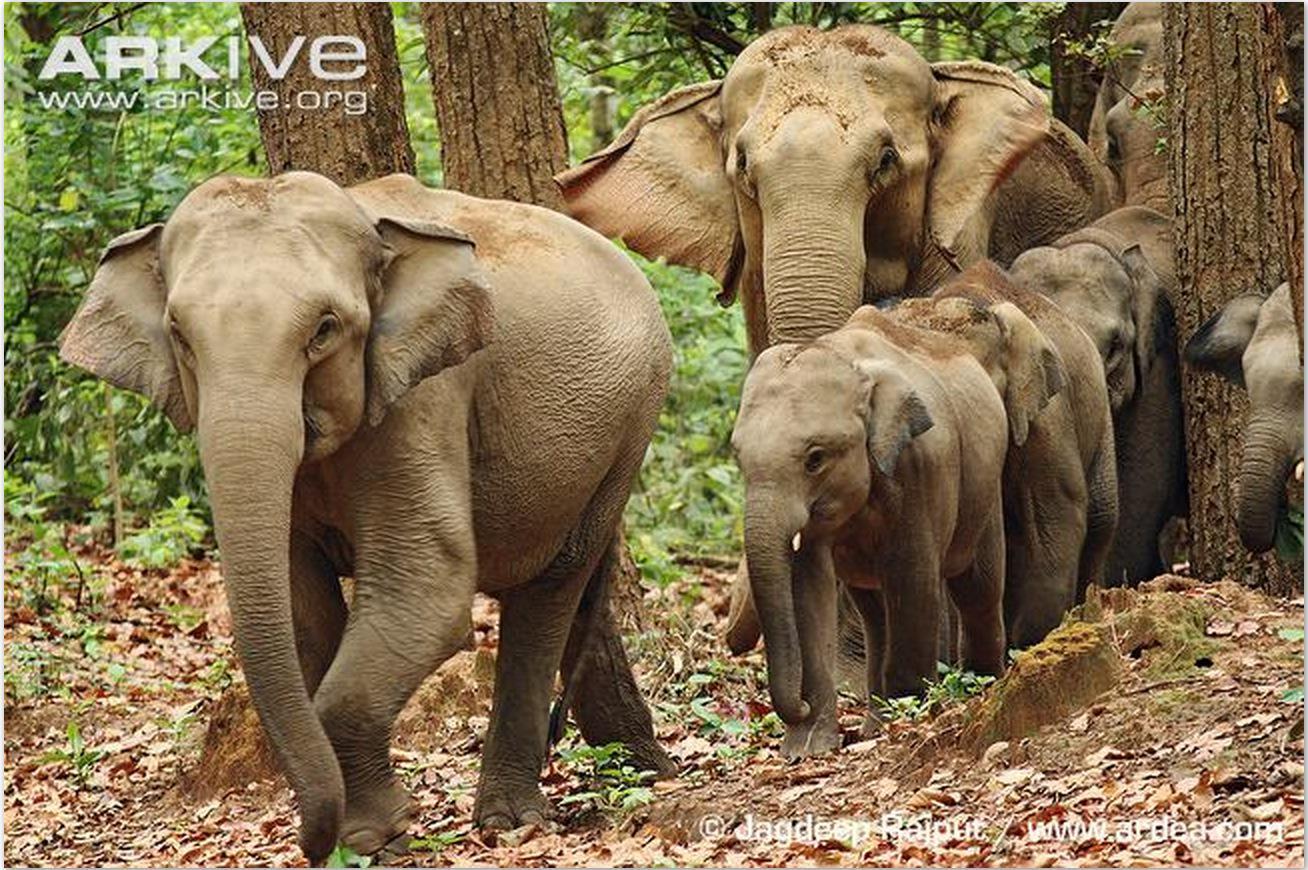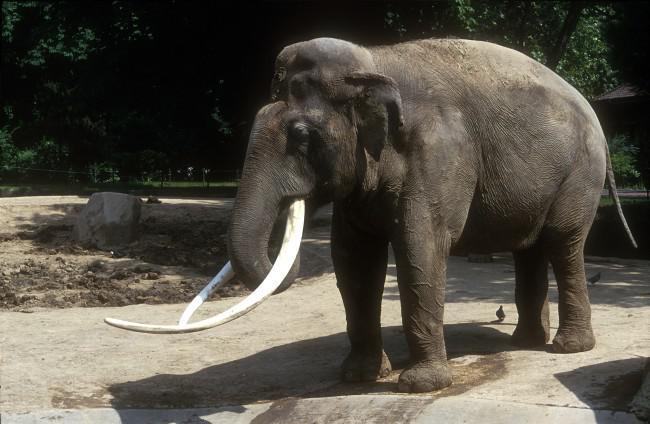The first image is the image on the left, the second image is the image on the right. Assess this claim about the two images: "There are no more than three elephants". Correct or not? Answer yes or no. No. 